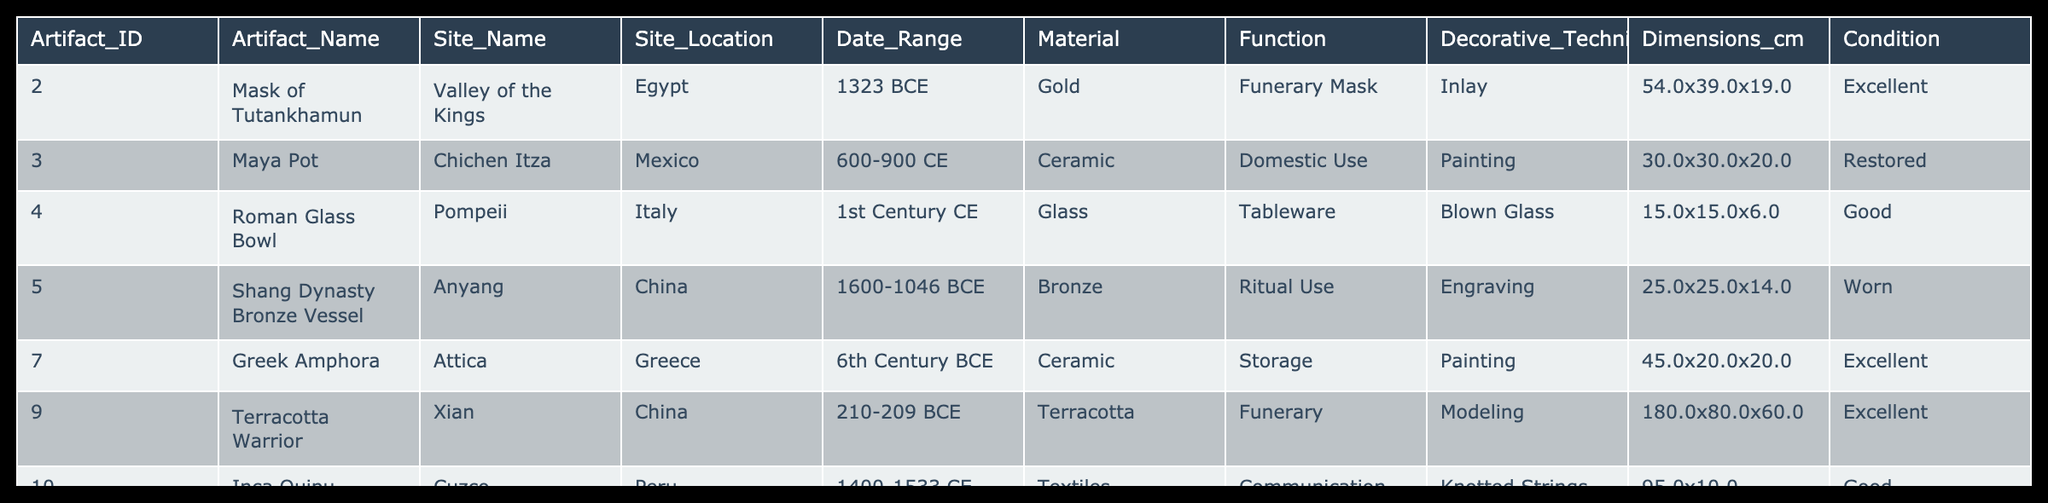What is the material used for the Mask of Tutankhamun? The table indicates that the artifact named "Mask of Tutankhamun" is made of gold, as stated in the "Material" column for Artifact_ID 2.
Answer: Gold Which artifact has the largest dimensions? The dimensions of the artifacts are listed in centimeters, and by comparing each, the "Terracotta Warrior" with dimensions 180.0x80.0x60.0 has the largest size.
Answer: Terracotta Warrior Is the Greek Amphora in excellent condition? In the table, the condition of the "Greek Amphora" is labeled as excellent, making it true that it's in excellent condition.
Answer: Yes How many artifacts are used for funerary purposes? The artifacts used for funerary purposes are the "Mask of Tutankhamun" and the "Terracotta Warrior", which can be counted from the "Function" column. Therefore, there are two artifacts.
Answer: 2 What is the average size (length) of the artifacts made from ceramic? The lengths of the ceramic artifacts, which are "Maya Pot" (30.0), "Greek Amphora" (45.0), and they sum to 75.0 cm; there are 2 artifacts, so the average length is 75.0 / 2 = 37.5 cm.
Answer: 37.5 Does any artifact from China date back to before 1000 BCE? The table shows one artifact from China, the "Shang Dynasty Bronze Vessel", with a date range of 1600-1046 BCE, confirming that there is an artifact from China that dates back before 1000 BCE.
Answer: Yes Which ceramic artifact is smaller in dimensions, the Maya Pot or the Greek Amphora? The dimensions of the "Maya Pot" are 30.0x30.0x20.0 and those of the "Greek Amphora" are 45.0x20.0x20.0. By comparing the volumes calculated from the dimensions, the Maya Pot is smaller.
Answer: Maya Pot What is the most commonly recognized archaeological date range among the artifacts listed? The date ranges vary among the artifacts, but examining the table, the modern date range (1400-1533 CE) for the "Inca Quipu" is seen, hence it's not as common as the ancient periods represented in the other artifacts.
Answer: No Which site presents artifacts dating back to the earliest period mentioned in the table? Upon reviewing the table, the "Shang Dynasty Bronze Vessel" from Anyang, China (1600-1046 BCE), is dated the earliest, making it the site with the oldest artifact.
Answer: Anyang 